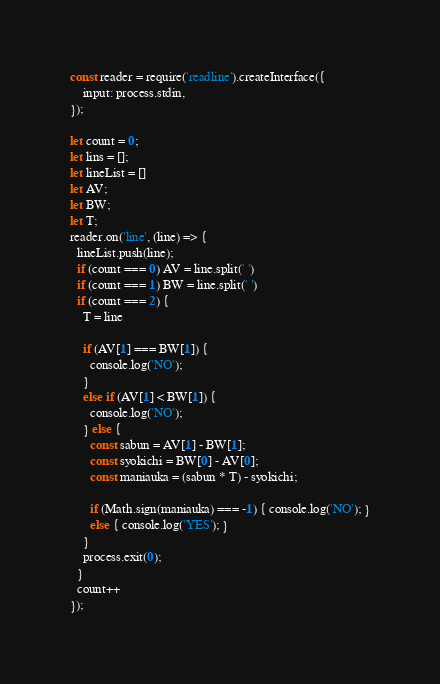<code> <loc_0><loc_0><loc_500><loc_500><_JavaScript_>const reader = require('readline').createInterface({
    input: process.stdin,
});

let count = 0;
let lins = [];
let lineList = []
let AV;
let BW;
let T;
reader.on('line', (line) => {
  lineList.push(line);
  if (count === 0) AV = line.split(' ')
  if (count === 1) BW = line.split(' ')
  if (count === 2) {
    T = line

    if (AV[1] === BW[1]) {
      console.log('NO');
    }
    else if (AV[1] < BW[1]) {
      console.log('NO');
    } else {
      const sabun = AV[1] - BW[1];
      const syokichi = BW[0] - AV[0];
      const maniauka = (sabun * T) - syokichi;

      if (Math.sign(maniauka) === -1) { console.log('NO'); }
      else { console.log('YES'); }
    }
    process.exit(0);
  }
  count++
});
</code> 